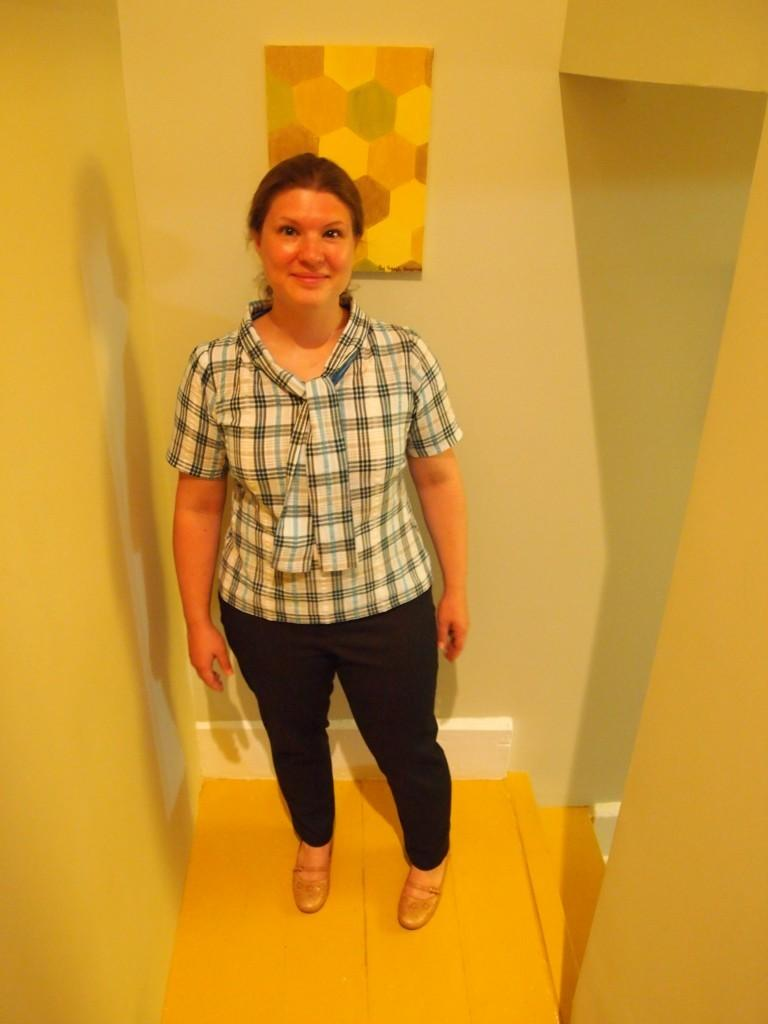Who is the main subject in the foreground of the image? There is a woman in the foreground of the image. What is the woman's position in the image? The woman is on the floor. What can be seen in the background of the image? There is a wall in the background of the image. Where might this image have been taken? The image may have been taken in a room, given the presence of a wall in the background. What type of celery is the woman holding in the image? There is no celery present in the image; the woman is on the floor without any visible objects in her hands. 